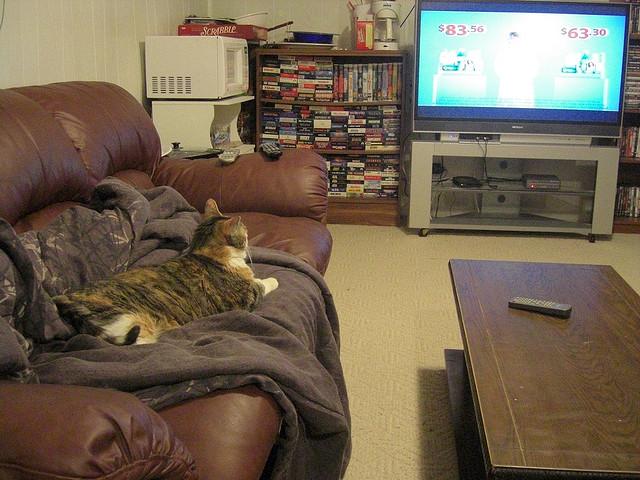What is the cat looking at?
Answer briefly. Tv. What shape is the coffee table?
Concise answer only. Rectangle. What is the cat laying on?
Answer briefly. Couch. 